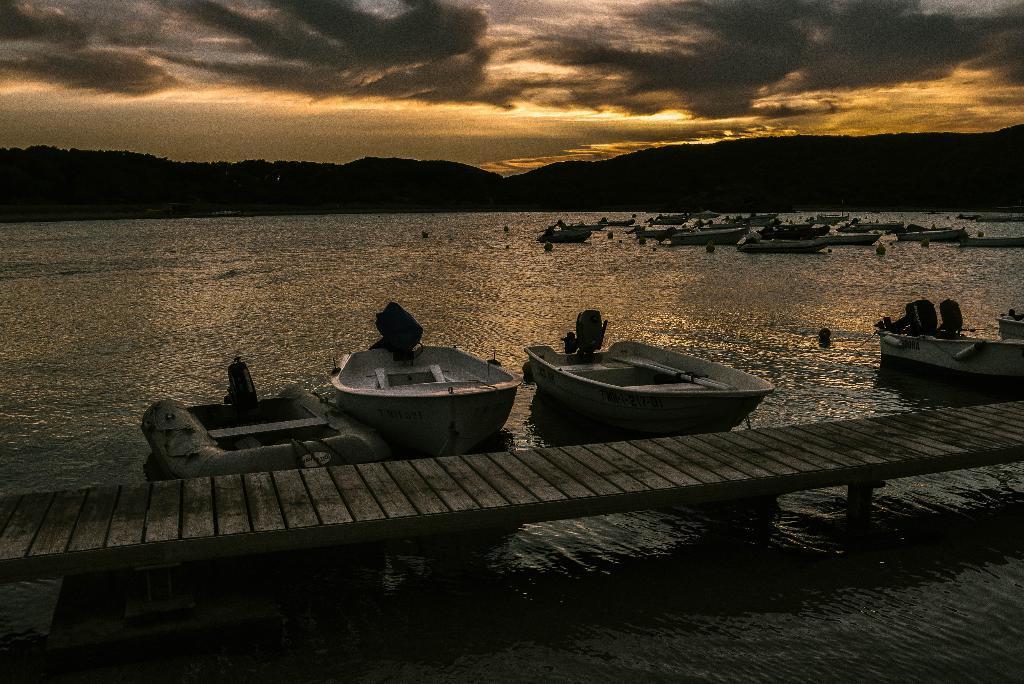Describe this image in one or two sentences. In this image, we can see some boats, there is a wooden bridge, we can see water and at the top there is a sky. 